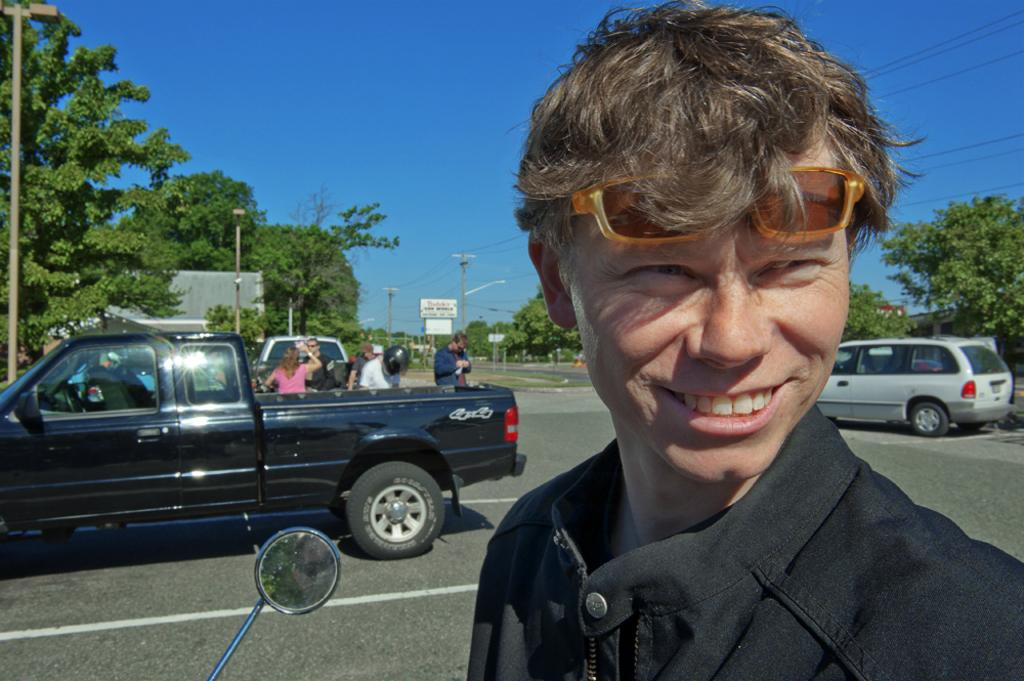Who is the main subject in the image? There is a man in the image. What is the man doing in the image? The man is looking at someone and smiling. Can you describe the background of the image? There are people visible in the background, and there are vehicles on the road. What is the color of the sky in the image? The sky is blue in the image. What type of cake is being served to the people in the image? There is no cake present in the image; it features a man looking at someone and smiling, with a background of people and vehicles. 